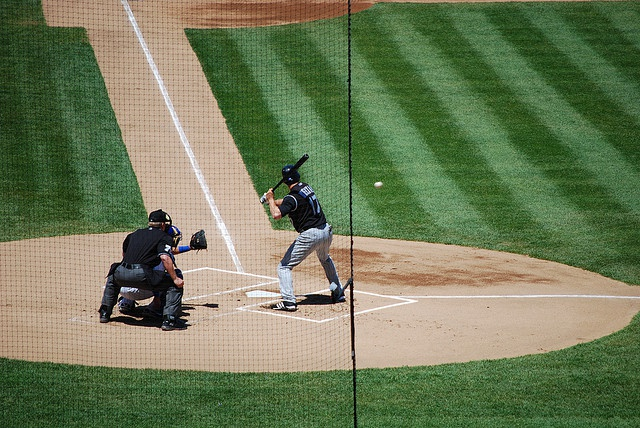Describe the objects in this image and their specific colors. I can see people in darkgreen, black, gray, lightgray, and darkgray tones, people in darkgreen, black, gray, and darkblue tones, people in darkgreen, black, gray, navy, and darkgray tones, baseball glove in darkgreen, black, gray, darkgray, and tan tones, and people in darkgreen, black, gray, tan, and blue tones in this image. 